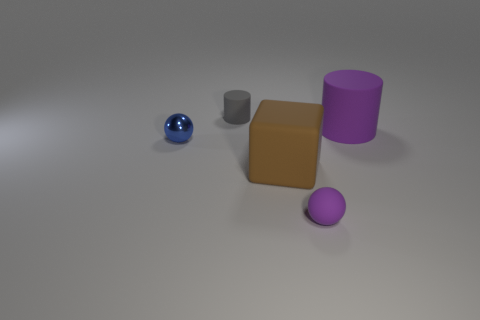Is there any other thing that has the same color as the large block?
Your response must be concise. No. There is a big rubber object to the right of the big object in front of the purple thing behind the brown rubber thing; what shape is it?
Provide a succinct answer. Cylinder. Does the purple object in front of the small blue metal ball have the same size as the rubber cylinder left of the small matte sphere?
Offer a very short reply. Yes. What number of small purple things have the same material as the big cube?
Make the answer very short. 1. There is a large rubber object that is left of the sphere that is in front of the small blue shiny sphere; how many cylinders are right of it?
Ensure brevity in your answer.  1. Does the gray object have the same shape as the big brown thing?
Your answer should be compact. No. Are there any purple objects of the same shape as the small blue shiny thing?
Your response must be concise. Yes. What is the shape of the blue thing that is the same size as the purple ball?
Offer a very short reply. Sphere. There is a small ball to the right of the tiny sphere on the left side of the gray thing right of the tiny shiny sphere; what is it made of?
Offer a very short reply. Rubber. Does the blue metal sphere have the same size as the purple matte cylinder?
Your answer should be very brief. No. 